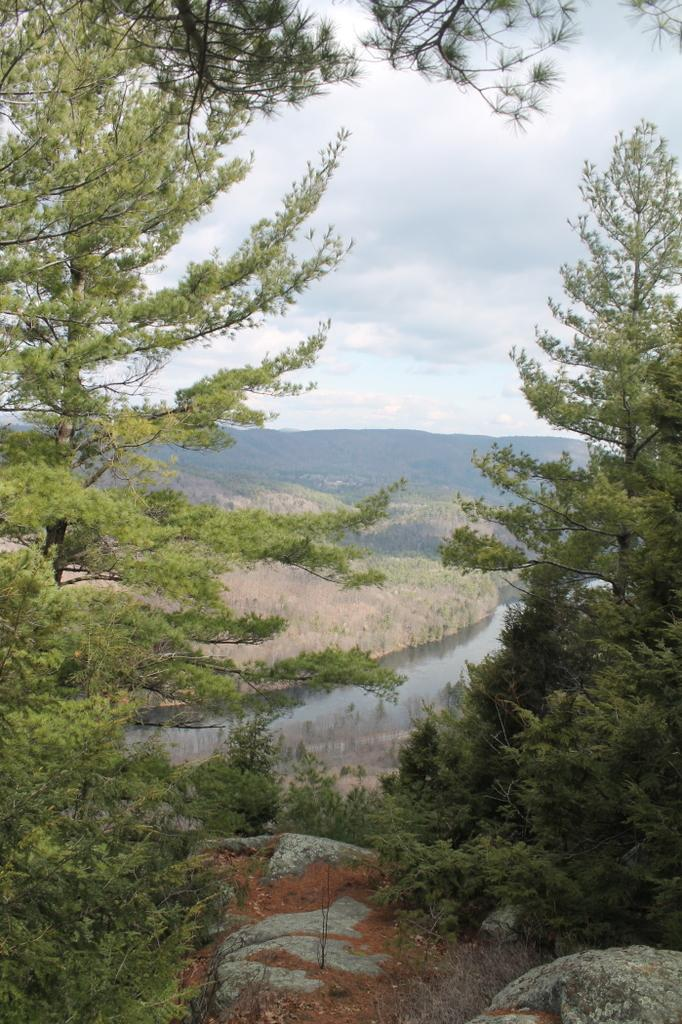What type of vegetation can be seen in the image? There are trees in the image. What is located in the middle of the image? There is a lake in the middle of the image. What can be seen in the background of the image? There are hills and clouds in the sky in the background of the image. How many bags are hanging on the trees in the image? There are no bags present in the image; it features trees, a lake, hills, and clouds. What type of grip does the hill have in the image? There is no mention of a grip or any interaction with the hill in the image. 